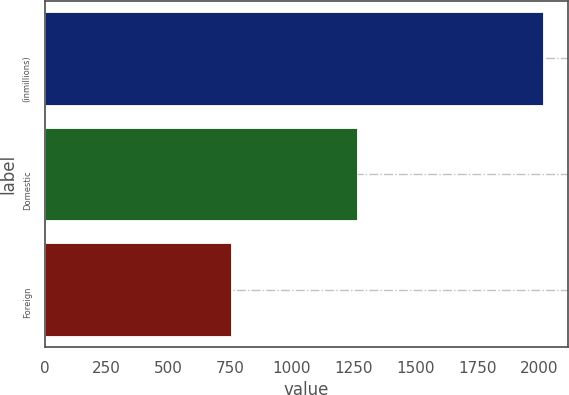Convert chart to OTSL. <chart><loc_0><loc_0><loc_500><loc_500><bar_chart><fcel>(inmillions)<fcel>Domestic<fcel>Foreign<nl><fcel>2014<fcel>1263<fcel>754<nl></chart> 